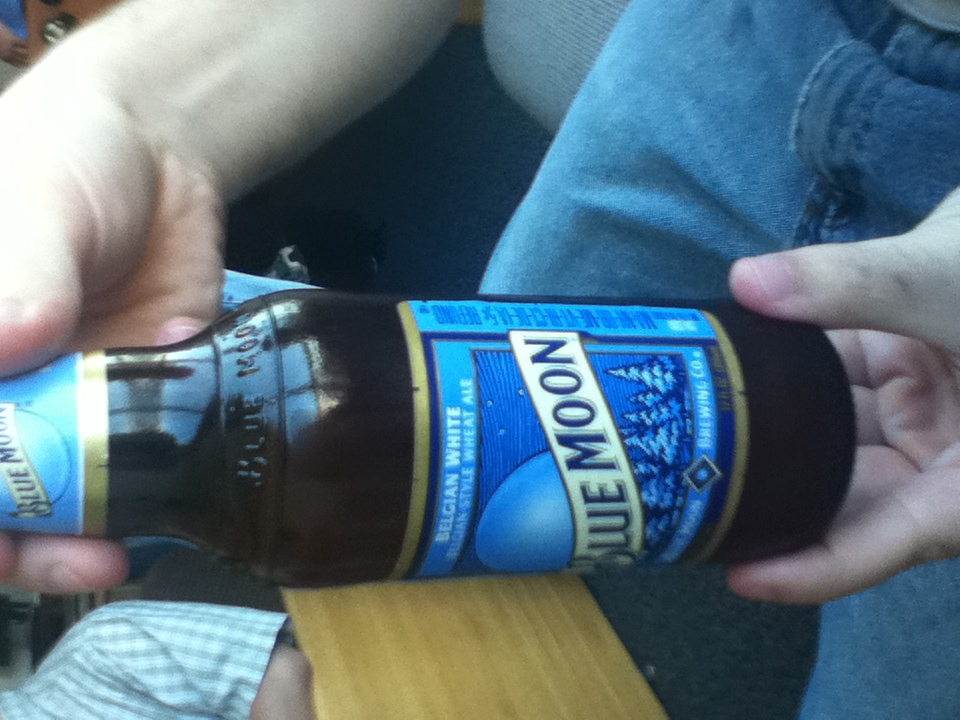What’s special about the brewing process of this type of beer? The brewing process of Blue Moon, a Belgian-style wheat ale, includes the use of white wheat and oats which gives it a smooth and creamy texture. Additionally, it's brewed with coriander and orange peel which imparts it with a distinctive citrus flavor that's quite refreshing. 